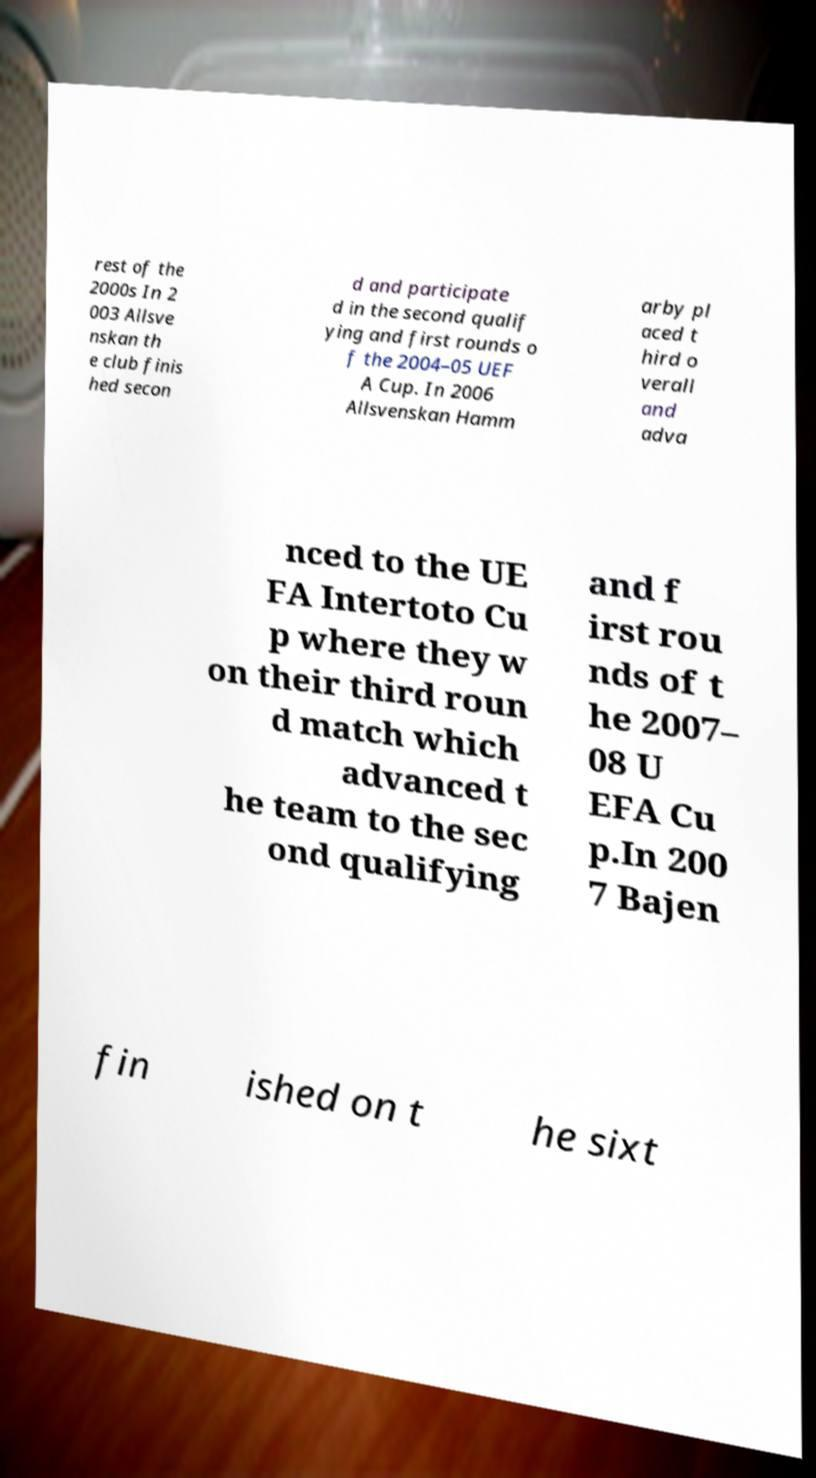Could you extract and type out the text from this image? rest of the 2000s In 2 003 Allsve nskan th e club finis hed secon d and participate d in the second qualif ying and first rounds o f the 2004–05 UEF A Cup. In 2006 Allsvenskan Hamm arby pl aced t hird o verall and adva nced to the UE FA Intertoto Cu p where they w on their third roun d match which advanced t he team to the sec ond qualifying and f irst rou nds of t he 2007– 08 U EFA Cu p.In 200 7 Bajen fin ished on t he sixt 